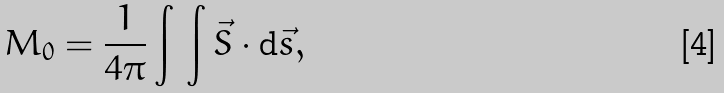<formula> <loc_0><loc_0><loc_500><loc_500>M _ { 0 } = \frac { 1 } { 4 \pi } \int \, \int \vec { S } \cdot { \mathrm d } \vec { s } ,</formula> 